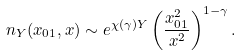Convert formula to latex. <formula><loc_0><loc_0><loc_500><loc_500>n _ { Y } ( x _ { 0 1 } , x ) \sim e ^ { \chi ( \gamma ) Y } \left ( \frac { x _ { 0 1 } ^ { 2 } } { x ^ { 2 } } \right ) ^ { 1 - \gamma } .</formula> 